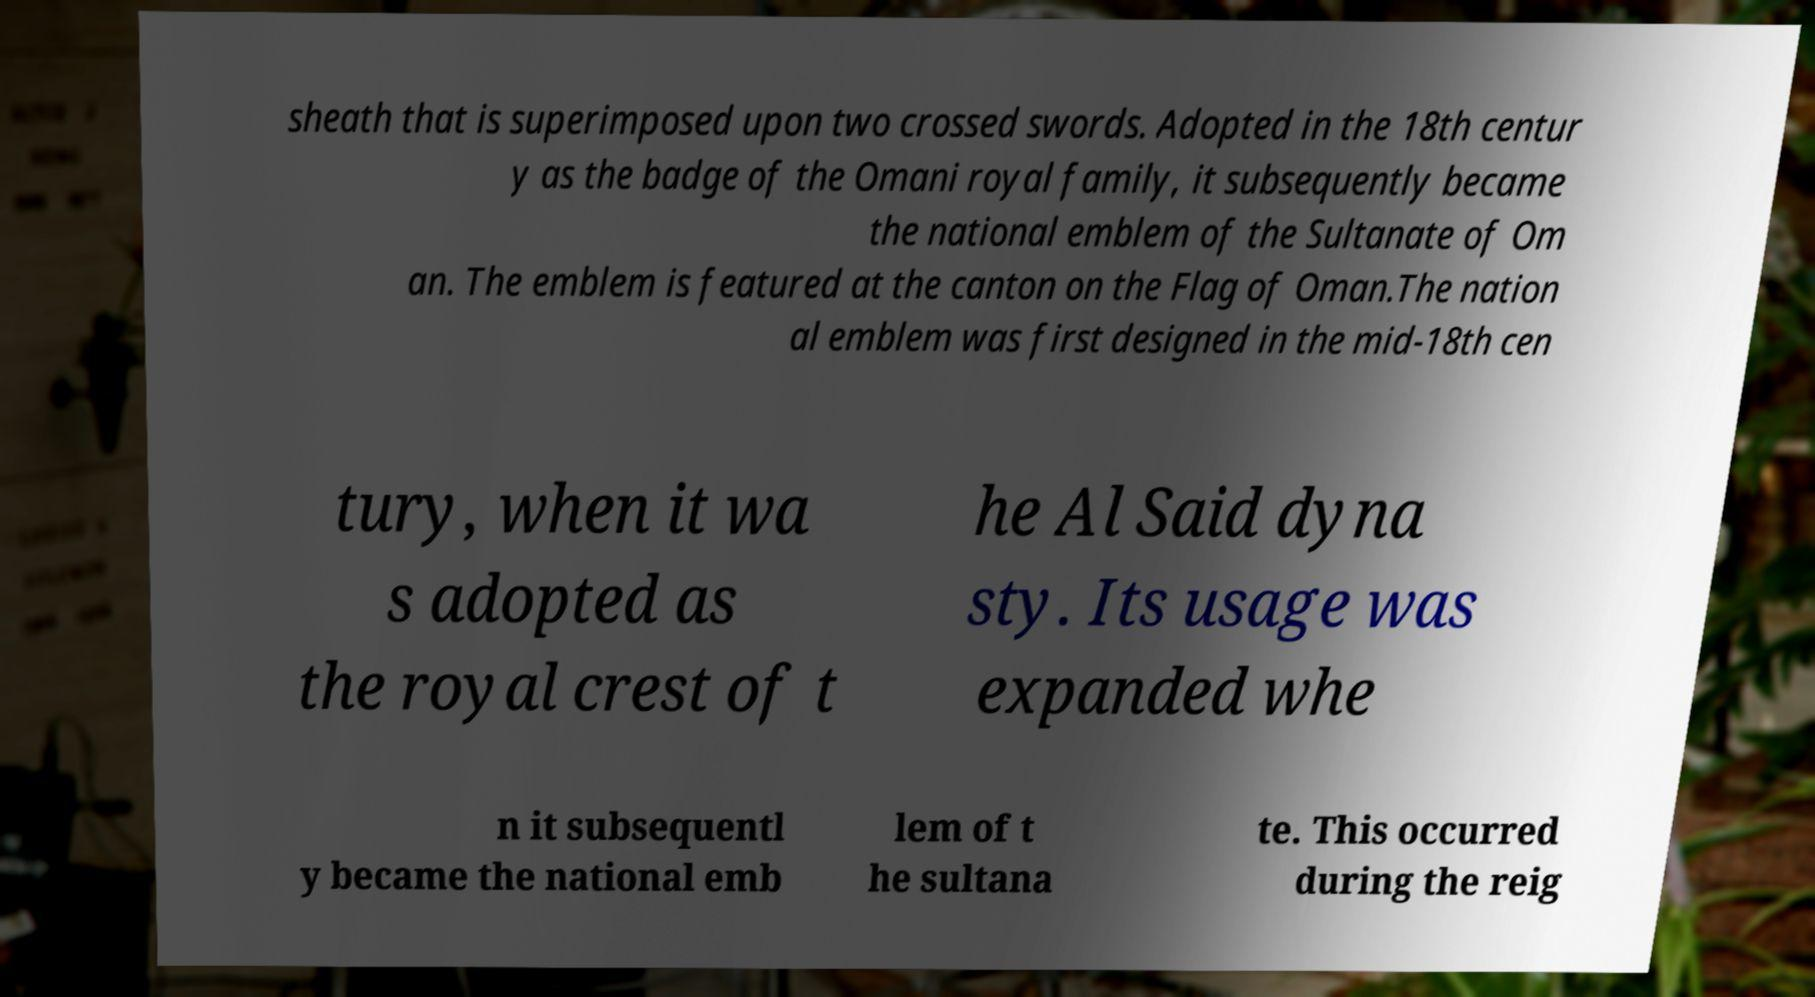There's text embedded in this image that I need extracted. Can you transcribe it verbatim? sheath that is superimposed upon two crossed swords. Adopted in the 18th centur y as the badge of the Omani royal family, it subsequently became the national emblem of the Sultanate of Om an. The emblem is featured at the canton on the Flag of Oman.The nation al emblem was first designed in the mid-18th cen tury, when it wa s adopted as the royal crest of t he Al Said dyna sty. Its usage was expanded whe n it subsequentl y became the national emb lem of t he sultana te. This occurred during the reig 